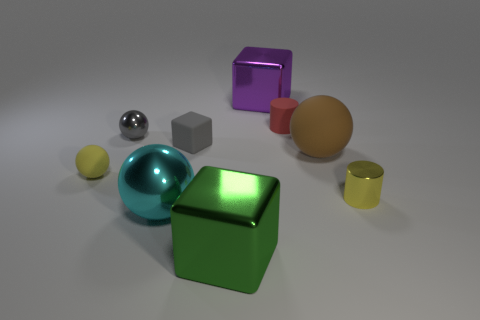Is there any other thing that is the same shape as the big green thing?
Your response must be concise. Yes. What number of large green things are to the right of the big green shiny cube?
Give a very brief answer. 0. Are there an equal number of red cylinders that are behind the cyan ball and big matte objects?
Keep it short and to the point. Yes. Are the big purple thing and the large green object made of the same material?
Ensure brevity in your answer.  Yes. What is the size of the thing that is both on the right side of the matte block and in front of the yellow metal cylinder?
Keep it short and to the point. Large. What number of red objects have the same size as the brown rubber ball?
Give a very brief answer. 0. How big is the cylinder to the right of the tiny rubber object that is to the right of the large purple cube?
Your answer should be very brief. Small. Does the yellow thing that is to the left of the tiny rubber cube have the same shape as the small metallic object right of the big brown matte ball?
Provide a short and direct response. No. What color is the block that is behind the large green object and in front of the small gray sphere?
Give a very brief answer. Gray. Is there a object of the same color as the small rubber sphere?
Offer a terse response. Yes. 